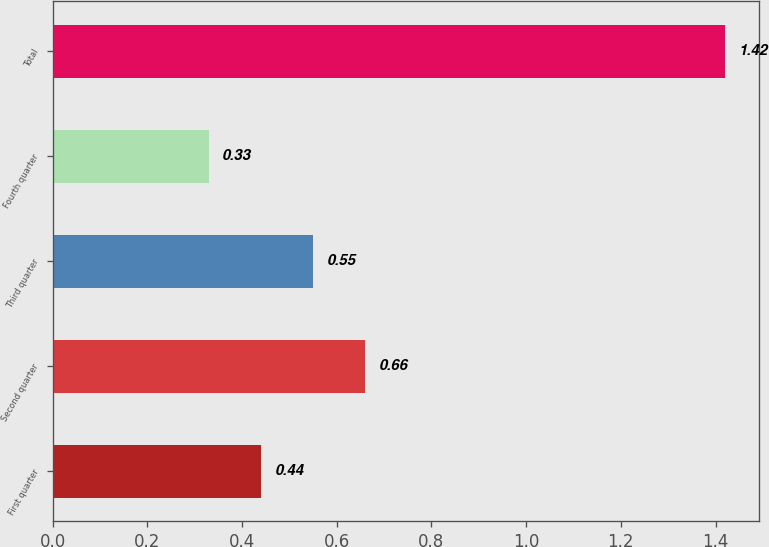Convert chart to OTSL. <chart><loc_0><loc_0><loc_500><loc_500><bar_chart><fcel>First quarter<fcel>Second quarter<fcel>Third quarter<fcel>Fourth quarter<fcel>Total<nl><fcel>0.44<fcel>0.66<fcel>0.55<fcel>0.33<fcel>1.42<nl></chart> 